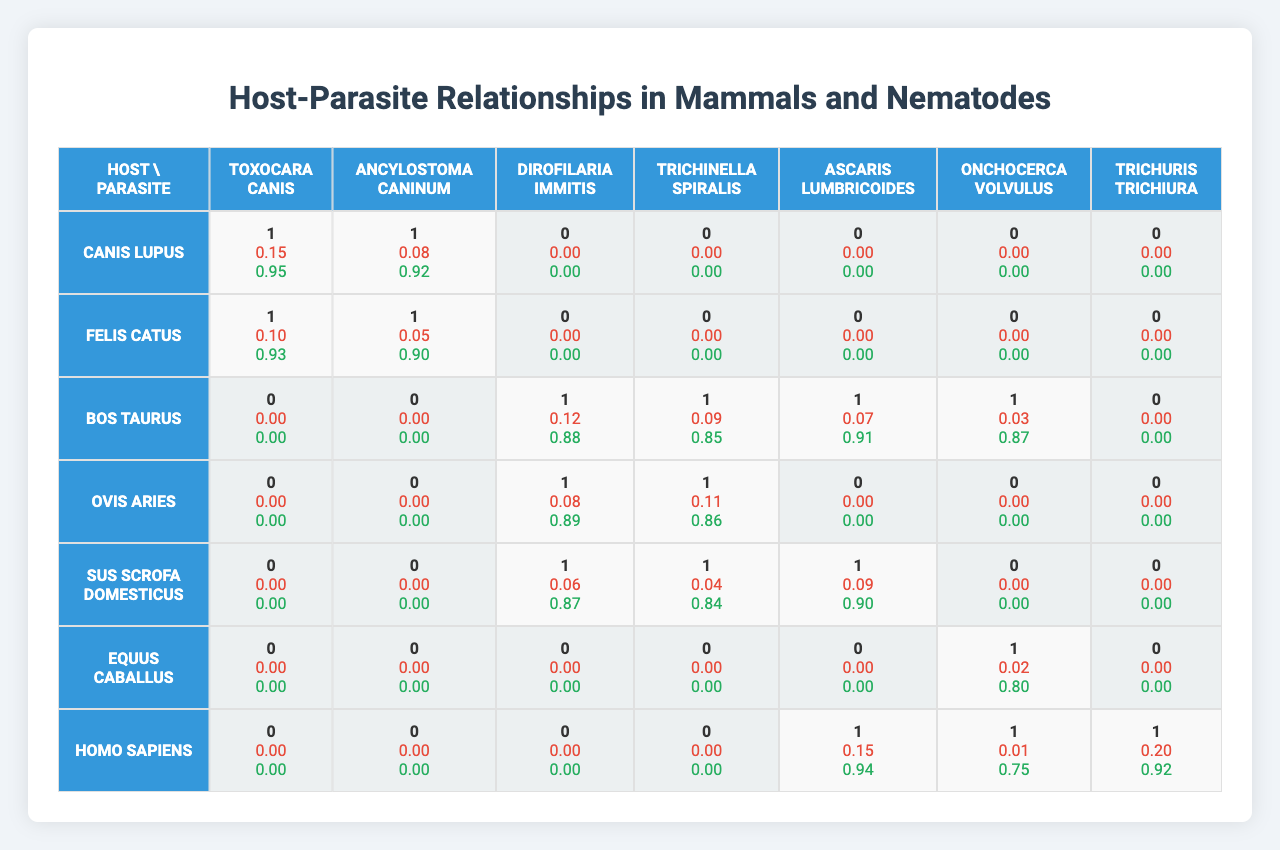What mammal hosts Toxocara canis? The table shows that Toxocara canis is associated with Canis lupus and Felis catus, as both of these hosts have a '1' in the corresponding column under Toxocara canis.
Answer: Canis lupus and Felis catus What is the infection rate of Dirofilaria immitis in Bos taurus? Looking at the row for Bos taurus and the column for Dirofilaria immitis, the infection rate is listed as 0.12.
Answer: 0.12 Is there a relationship between Homo sapiens and Trichuris trichiura? The table indicates that Homo sapiens has a '1' in the column for Trichuris trichiura, which means there is a relationship.
Answer: Yes Which parasite has the highest treatment efficacy for Sus scrofa domesticus? For Sus scrofa domesticus, the treatment efficacies listed are 0.87, 0.84, 0.90, 0, 0, 0, and 0. Thus, the highest treatment efficacy is 0.90 for Ascaris lumbricoides.
Answer: 0.90 What is the average infection rate of Trichinella spiralis across all hosts? The infection rates for Trichinella spiralis among the hosts are 0.09 (Bos taurus), 0.11 (Ovis aries), 0 (Sus scrofa domesticus), 0 (Equus caballus), 0 (Homo sapiens). The sum is 0.09 + 0.11 = 0.20, and there are 5 values. Thus, the average infection rate is 0.20 / 5 = 0.04.
Answer: 0.04 Which host has the lowest infection rate for Ancylostoma caninum? The infection rates for Ancylostoma caninum listed under each host are 0.08 (Canis lupus), 0.05 (Felis catus), and 0 (Bos taurus, Ovis aries, Sus scrofa domesticus, Equus caballus, Homo sapiens). The lowest infection rate is 0.
Answer: 0 How does the treatment efficacy for Toxocara canis in Felis catus compare to that in Canis lupus? In the table, the treatment efficacy for Toxocara canis in Felis catus is 0.90, while in Canis lupus it is 0.92. Comparing the two shows that Canis lupus has a higher treatment efficacy.
Answer: Canis lupus has a higher efficacy Which parasite has the highest overall treatment efficacy across all hosts? The treatment efficacies across parasites are: Toxocara canis (0.95, 0.93), Ancylostoma caninum (0.92, 0.90), Dirofilaria immitis (0.88), Trichinella spiralis (0.89), Ascaris lumbricoides (0.91, 0.87), Onchocerca volvulus (0.80), Trichuris trichiura (0.94). The highest value is 0.95 for Toxocara canis in Canis lupus.
Answer: Toxocara canis What is the total number of relationships (counting '1's) between hosts and the parasite Onchocerca volvulus? In the relationships column for Onchocerca volvulus, the counts are 0 (Canis lupus, Felis catus, Bos taurus, Ovis aries, Sus scrofa domesticus) and 1 (Equus caballus, Homo sapiens). This gives a total of 2 relationships.
Answer: 2 In terms of infection rates, how does the relationship between Bos taurus and both Dirofilaria immitis and Onchocerca volvulus compare? The infection rate of Dirofilaria immitis in Bos taurus is 0.12, while for Onchocerca volvulus it is 0.03. Hence, the infection rate for Dirofilaria immitis is higher than that for Onchocerca volvulus.
Answer: Dirofilaria immitis is higher 